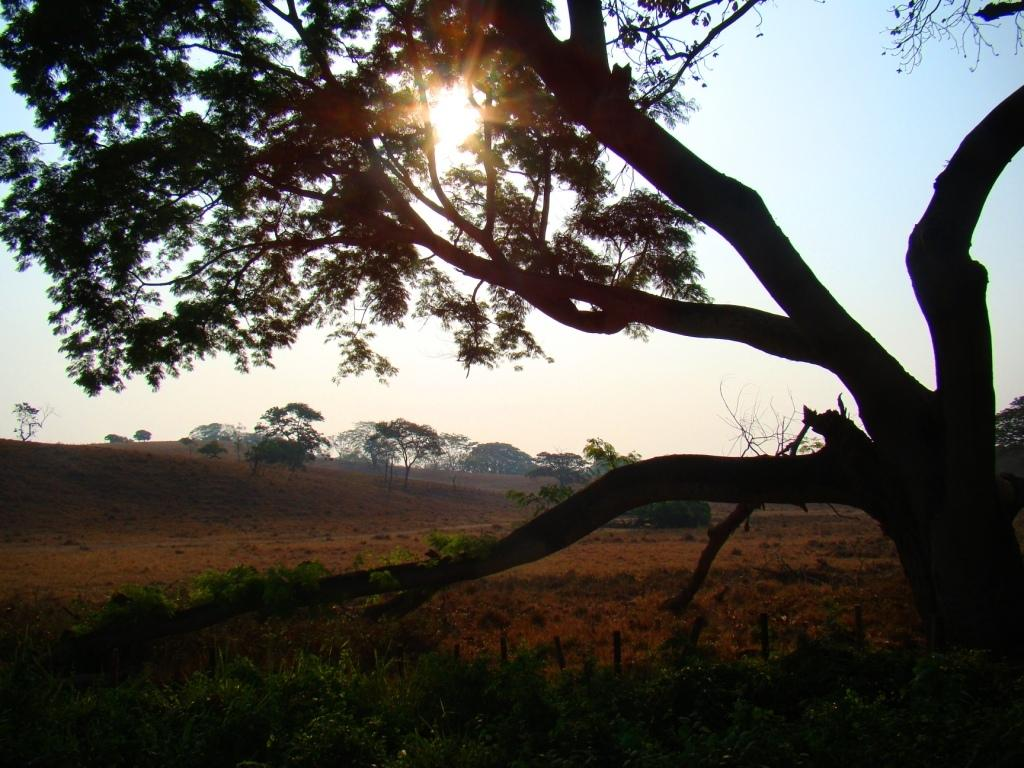What types of plants can be seen in the foreground of the picture? There are plants and a tree in the foreground of the picture. What type of vegetation is present in the foreground of the picture? There is grass in the foreground of the picture. What can be seen in the center of the picture? There is dry land in the center of the picture. What is visible in the background of the picture? There are trees in the background of the picture. What part of the natural environment is visible in the picture? The sky is visible in the image. Can the sun be seen in the picture? Yes, the sun is visible in the sky. Are there any farmers or seeds visible in the image? There are no farmers or seeds present in the image. Can you see any dinosaurs in the image? There are no dinosaurs present in the image. 